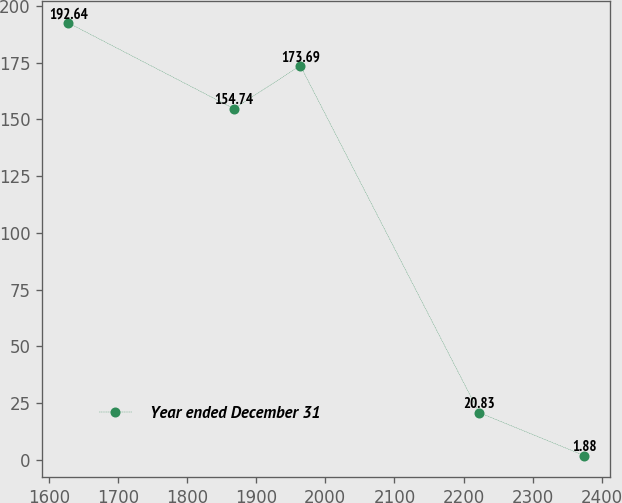Convert chart to OTSL. <chart><loc_0><loc_0><loc_500><loc_500><line_chart><ecel><fcel>Year ended December 31<nl><fcel>1627.56<fcel>192.64<nl><fcel>1867.75<fcel>154.74<nl><fcel>1963.86<fcel>173.69<nl><fcel>2222.5<fcel>20.83<nl><fcel>2374.77<fcel>1.88<nl></chart> 